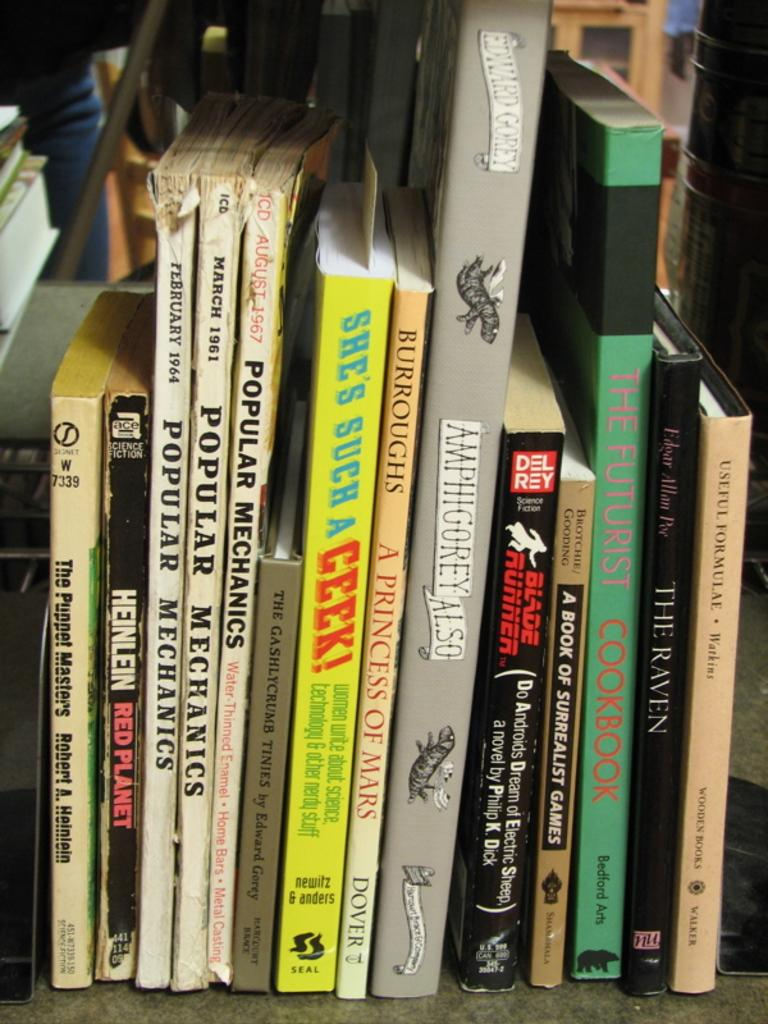<image>
Present a compact description of the photo's key features. Several books lined up on a shelf with titles like SHE'S SUCH A GEEK! 